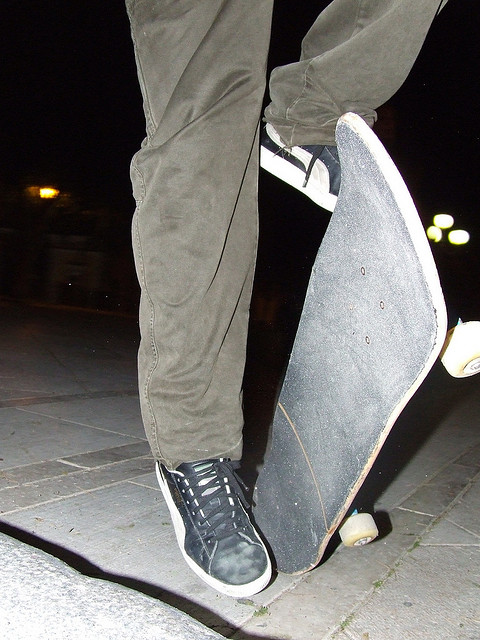<image>What are the two letters shown on the ground? There are no letters shown on the ground. What are the two letters shown on the ground? There are no letters shown on the ground. 